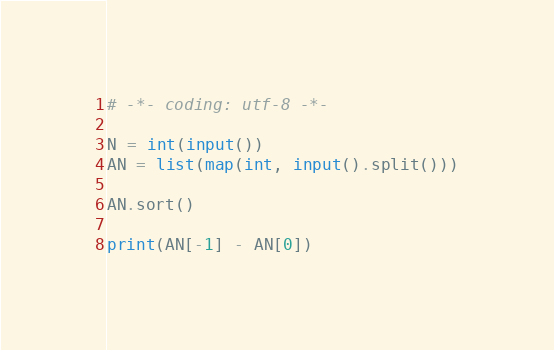Convert code to text. <code><loc_0><loc_0><loc_500><loc_500><_Python_># -*- coding: utf-8 -*-

N = int(input())
AN = list(map(int, input().split()))

AN.sort()

print(AN[-1] - AN[0])</code> 